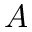Convert formula to latex. <formula><loc_0><loc_0><loc_500><loc_500>A</formula> 